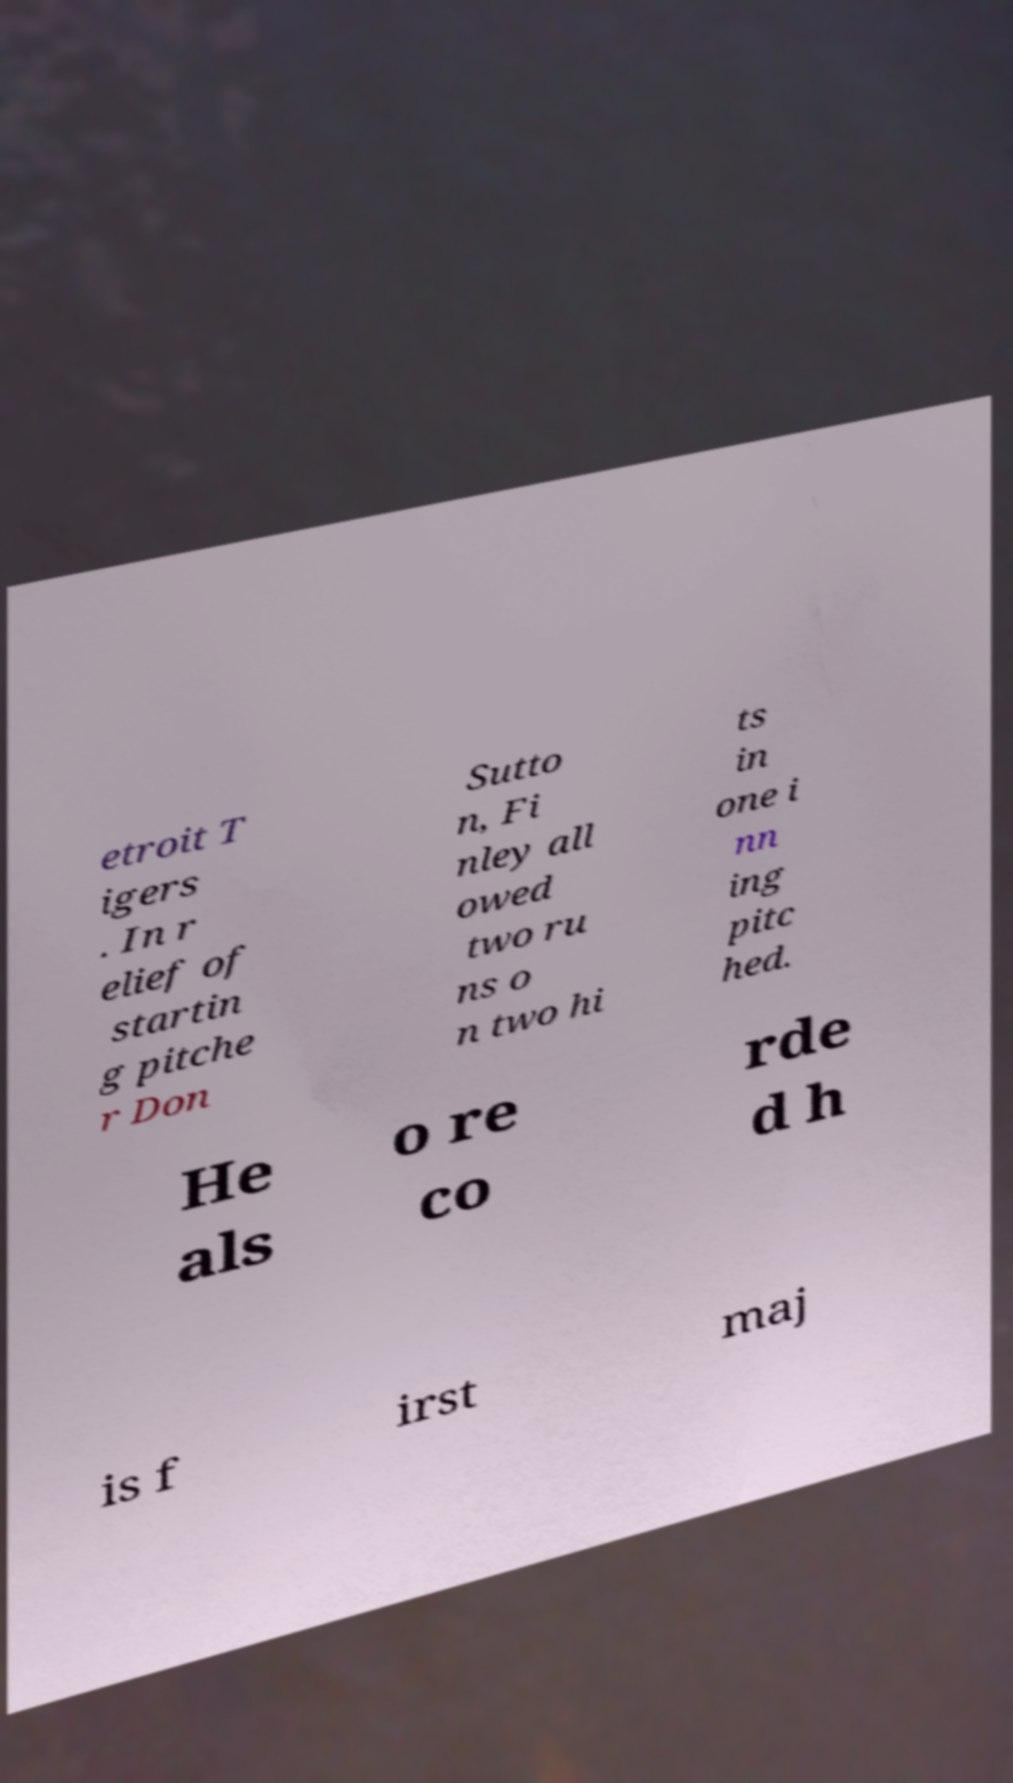Can you accurately transcribe the text from the provided image for me? etroit T igers . In r elief of startin g pitche r Don Sutto n, Fi nley all owed two ru ns o n two hi ts in one i nn ing pitc hed. He als o re co rde d h is f irst maj 